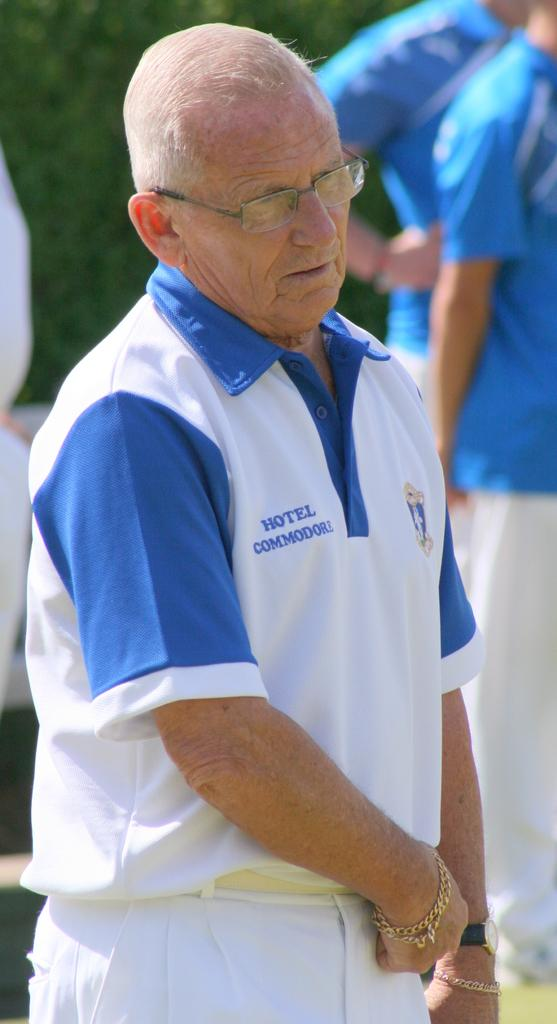<image>
Share a concise interpretation of the image provided. A old man with white hair is working at Hotel Commodore. 